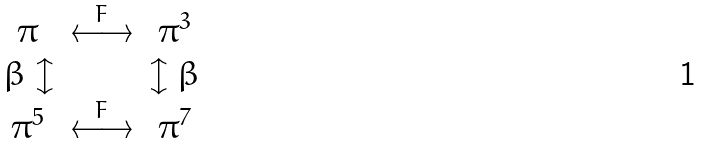<formula> <loc_0><loc_0><loc_500><loc_500>\begin{matrix} \pi & \overset { F } { \longleftrightarrow } & \pi ^ { 3 } \\ \beta \updownarrow & & \updownarrow \beta \\ \pi ^ { 5 } & \overset { F } { \longleftrightarrow } & \pi ^ { 7 } \\ \end{matrix}</formula> 